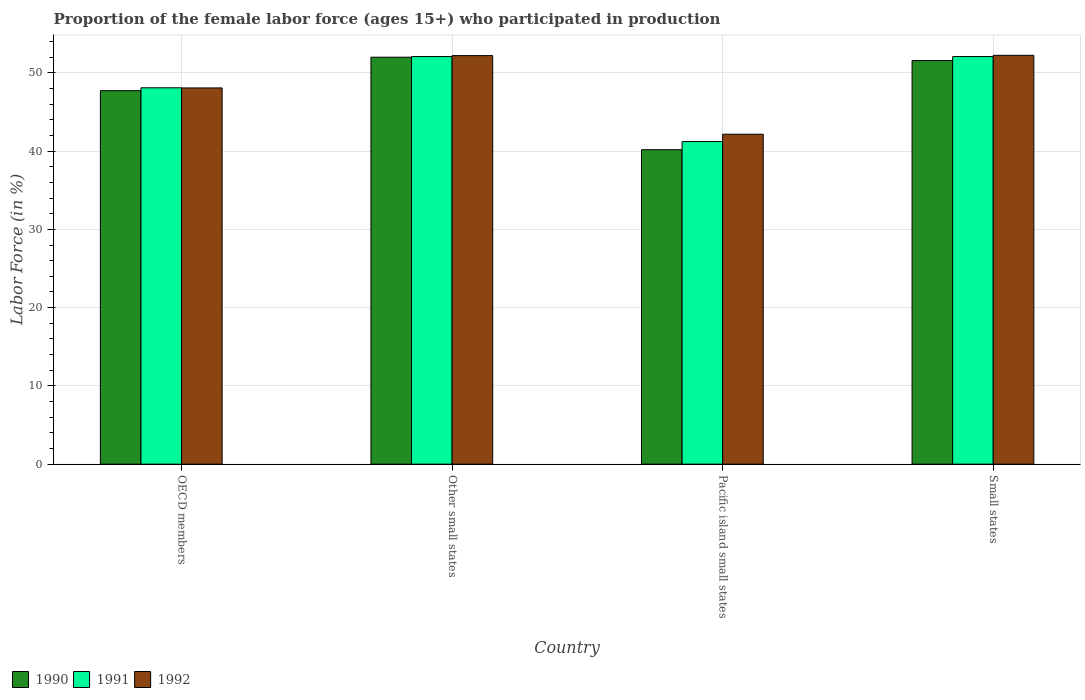How many different coloured bars are there?
Provide a succinct answer. 3. How many bars are there on the 4th tick from the right?
Provide a short and direct response. 3. What is the label of the 4th group of bars from the left?
Your answer should be compact. Small states. In how many cases, is the number of bars for a given country not equal to the number of legend labels?
Keep it short and to the point. 0. What is the proportion of the female labor force who participated in production in 1990 in Small states?
Your answer should be very brief. 51.57. Across all countries, what is the maximum proportion of the female labor force who participated in production in 1990?
Provide a succinct answer. 52. Across all countries, what is the minimum proportion of the female labor force who participated in production in 1990?
Your answer should be compact. 40.18. In which country was the proportion of the female labor force who participated in production in 1991 maximum?
Provide a short and direct response. Small states. In which country was the proportion of the female labor force who participated in production in 1990 minimum?
Your answer should be compact. Pacific island small states. What is the total proportion of the female labor force who participated in production in 1992 in the graph?
Offer a terse response. 194.66. What is the difference between the proportion of the female labor force who participated in production in 1991 in OECD members and that in Pacific island small states?
Ensure brevity in your answer.  6.87. What is the difference between the proportion of the female labor force who participated in production in 1991 in Pacific island small states and the proportion of the female labor force who participated in production in 1992 in Other small states?
Your answer should be compact. -10.98. What is the average proportion of the female labor force who participated in production in 1992 per country?
Your answer should be very brief. 48.66. What is the difference between the proportion of the female labor force who participated in production of/in 1991 and proportion of the female labor force who participated in production of/in 1990 in Other small states?
Make the answer very short. 0.08. What is the ratio of the proportion of the female labor force who participated in production in 1992 in OECD members to that in Pacific island small states?
Offer a terse response. 1.14. What is the difference between the highest and the second highest proportion of the female labor force who participated in production in 1990?
Provide a succinct answer. -0.43. What is the difference between the highest and the lowest proportion of the female labor force who participated in production in 1992?
Your response must be concise. 10.08. Is the sum of the proportion of the female labor force who participated in production in 1991 in Pacific island small states and Small states greater than the maximum proportion of the female labor force who participated in production in 1992 across all countries?
Offer a terse response. Yes. What does the 1st bar from the left in Other small states represents?
Your answer should be very brief. 1990. What does the 2nd bar from the right in Small states represents?
Your answer should be compact. 1991. How many bars are there?
Keep it short and to the point. 12. Does the graph contain grids?
Ensure brevity in your answer.  Yes. What is the title of the graph?
Make the answer very short. Proportion of the female labor force (ages 15+) who participated in production. What is the label or title of the X-axis?
Make the answer very short. Country. What is the Labor Force (in %) of 1990 in OECD members?
Your response must be concise. 47.72. What is the Labor Force (in %) in 1991 in OECD members?
Keep it short and to the point. 48.09. What is the Labor Force (in %) of 1992 in OECD members?
Your answer should be very brief. 48.07. What is the Labor Force (in %) of 1990 in Other small states?
Your answer should be compact. 52. What is the Labor Force (in %) in 1991 in Other small states?
Ensure brevity in your answer.  52.08. What is the Labor Force (in %) of 1992 in Other small states?
Provide a short and direct response. 52.2. What is the Labor Force (in %) of 1990 in Pacific island small states?
Your answer should be compact. 40.18. What is the Labor Force (in %) in 1991 in Pacific island small states?
Give a very brief answer. 41.21. What is the Labor Force (in %) in 1992 in Pacific island small states?
Give a very brief answer. 42.15. What is the Labor Force (in %) of 1990 in Small states?
Keep it short and to the point. 51.57. What is the Labor Force (in %) of 1991 in Small states?
Offer a terse response. 52.08. What is the Labor Force (in %) in 1992 in Small states?
Your answer should be very brief. 52.24. Across all countries, what is the maximum Labor Force (in %) of 1990?
Offer a terse response. 52. Across all countries, what is the maximum Labor Force (in %) of 1991?
Offer a terse response. 52.08. Across all countries, what is the maximum Labor Force (in %) of 1992?
Give a very brief answer. 52.24. Across all countries, what is the minimum Labor Force (in %) of 1990?
Ensure brevity in your answer.  40.18. Across all countries, what is the minimum Labor Force (in %) of 1991?
Ensure brevity in your answer.  41.21. Across all countries, what is the minimum Labor Force (in %) of 1992?
Keep it short and to the point. 42.15. What is the total Labor Force (in %) of 1990 in the graph?
Offer a very short reply. 191.46. What is the total Labor Force (in %) of 1991 in the graph?
Your response must be concise. 193.46. What is the total Labor Force (in %) of 1992 in the graph?
Provide a short and direct response. 194.66. What is the difference between the Labor Force (in %) of 1990 in OECD members and that in Other small states?
Provide a short and direct response. -4.28. What is the difference between the Labor Force (in %) in 1991 in OECD members and that in Other small states?
Ensure brevity in your answer.  -3.99. What is the difference between the Labor Force (in %) of 1992 in OECD members and that in Other small states?
Your response must be concise. -4.13. What is the difference between the Labor Force (in %) of 1990 in OECD members and that in Pacific island small states?
Offer a terse response. 7.54. What is the difference between the Labor Force (in %) of 1991 in OECD members and that in Pacific island small states?
Your answer should be very brief. 6.87. What is the difference between the Labor Force (in %) in 1992 in OECD members and that in Pacific island small states?
Your response must be concise. 5.92. What is the difference between the Labor Force (in %) of 1990 in OECD members and that in Small states?
Ensure brevity in your answer.  -3.85. What is the difference between the Labor Force (in %) in 1991 in OECD members and that in Small states?
Make the answer very short. -3.99. What is the difference between the Labor Force (in %) in 1992 in OECD members and that in Small states?
Provide a succinct answer. -4.17. What is the difference between the Labor Force (in %) in 1990 in Other small states and that in Pacific island small states?
Make the answer very short. 11.82. What is the difference between the Labor Force (in %) of 1991 in Other small states and that in Pacific island small states?
Your response must be concise. 10.86. What is the difference between the Labor Force (in %) in 1992 in Other small states and that in Pacific island small states?
Ensure brevity in your answer.  10.04. What is the difference between the Labor Force (in %) in 1990 in Other small states and that in Small states?
Your answer should be compact. 0.43. What is the difference between the Labor Force (in %) of 1991 in Other small states and that in Small states?
Your answer should be compact. -0. What is the difference between the Labor Force (in %) of 1992 in Other small states and that in Small states?
Your answer should be very brief. -0.04. What is the difference between the Labor Force (in %) in 1990 in Pacific island small states and that in Small states?
Your response must be concise. -11.39. What is the difference between the Labor Force (in %) of 1991 in Pacific island small states and that in Small states?
Offer a very short reply. -10.86. What is the difference between the Labor Force (in %) in 1992 in Pacific island small states and that in Small states?
Your response must be concise. -10.08. What is the difference between the Labor Force (in %) of 1990 in OECD members and the Labor Force (in %) of 1991 in Other small states?
Offer a terse response. -4.36. What is the difference between the Labor Force (in %) of 1990 in OECD members and the Labor Force (in %) of 1992 in Other small states?
Provide a succinct answer. -4.48. What is the difference between the Labor Force (in %) in 1991 in OECD members and the Labor Force (in %) in 1992 in Other small states?
Your answer should be compact. -4.11. What is the difference between the Labor Force (in %) in 1990 in OECD members and the Labor Force (in %) in 1991 in Pacific island small states?
Ensure brevity in your answer.  6.5. What is the difference between the Labor Force (in %) of 1990 in OECD members and the Labor Force (in %) of 1992 in Pacific island small states?
Offer a terse response. 5.57. What is the difference between the Labor Force (in %) in 1991 in OECD members and the Labor Force (in %) in 1992 in Pacific island small states?
Keep it short and to the point. 5.93. What is the difference between the Labor Force (in %) of 1990 in OECD members and the Labor Force (in %) of 1991 in Small states?
Your answer should be compact. -4.36. What is the difference between the Labor Force (in %) in 1990 in OECD members and the Labor Force (in %) in 1992 in Small states?
Keep it short and to the point. -4.52. What is the difference between the Labor Force (in %) of 1991 in OECD members and the Labor Force (in %) of 1992 in Small states?
Make the answer very short. -4.15. What is the difference between the Labor Force (in %) in 1990 in Other small states and the Labor Force (in %) in 1991 in Pacific island small states?
Your answer should be compact. 10.78. What is the difference between the Labor Force (in %) in 1990 in Other small states and the Labor Force (in %) in 1992 in Pacific island small states?
Provide a succinct answer. 9.84. What is the difference between the Labor Force (in %) of 1991 in Other small states and the Labor Force (in %) of 1992 in Pacific island small states?
Keep it short and to the point. 9.92. What is the difference between the Labor Force (in %) in 1990 in Other small states and the Labor Force (in %) in 1991 in Small states?
Give a very brief answer. -0.08. What is the difference between the Labor Force (in %) of 1990 in Other small states and the Labor Force (in %) of 1992 in Small states?
Provide a succinct answer. -0.24. What is the difference between the Labor Force (in %) of 1991 in Other small states and the Labor Force (in %) of 1992 in Small states?
Offer a very short reply. -0.16. What is the difference between the Labor Force (in %) in 1990 in Pacific island small states and the Labor Force (in %) in 1991 in Small states?
Your answer should be very brief. -11.9. What is the difference between the Labor Force (in %) of 1990 in Pacific island small states and the Labor Force (in %) of 1992 in Small states?
Offer a very short reply. -12.06. What is the difference between the Labor Force (in %) in 1991 in Pacific island small states and the Labor Force (in %) in 1992 in Small states?
Provide a succinct answer. -11.02. What is the average Labor Force (in %) in 1990 per country?
Ensure brevity in your answer.  47.86. What is the average Labor Force (in %) of 1991 per country?
Your response must be concise. 48.36. What is the average Labor Force (in %) of 1992 per country?
Your response must be concise. 48.66. What is the difference between the Labor Force (in %) in 1990 and Labor Force (in %) in 1991 in OECD members?
Provide a short and direct response. -0.37. What is the difference between the Labor Force (in %) in 1990 and Labor Force (in %) in 1992 in OECD members?
Your answer should be compact. -0.35. What is the difference between the Labor Force (in %) in 1991 and Labor Force (in %) in 1992 in OECD members?
Your answer should be compact. 0.02. What is the difference between the Labor Force (in %) of 1990 and Labor Force (in %) of 1991 in Other small states?
Offer a very short reply. -0.08. What is the difference between the Labor Force (in %) in 1990 and Labor Force (in %) in 1992 in Other small states?
Offer a terse response. -0.2. What is the difference between the Labor Force (in %) of 1991 and Labor Force (in %) of 1992 in Other small states?
Ensure brevity in your answer.  -0.12. What is the difference between the Labor Force (in %) of 1990 and Labor Force (in %) of 1991 in Pacific island small states?
Offer a very short reply. -1.04. What is the difference between the Labor Force (in %) in 1990 and Labor Force (in %) in 1992 in Pacific island small states?
Offer a terse response. -1.98. What is the difference between the Labor Force (in %) of 1991 and Labor Force (in %) of 1992 in Pacific island small states?
Offer a very short reply. -0.94. What is the difference between the Labor Force (in %) in 1990 and Labor Force (in %) in 1991 in Small states?
Your answer should be very brief. -0.51. What is the difference between the Labor Force (in %) in 1990 and Labor Force (in %) in 1992 in Small states?
Your answer should be very brief. -0.67. What is the difference between the Labor Force (in %) of 1991 and Labor Force (in %) of 1992 in Small states?
Give a very brief answer. -0.16. What is the ratio of the Labor Force (in %) in 1990 in OECD members to that in Other small states?
Provide a succinct answer. 0.92. What is the ratio of the Labor Force (in %) in 1991 in OECD members to that in Other small states?
Give a very brief answer. 0.92. What is the ratio of the Labor Force (in %) in 1992 in OECD members to that in Other small states?
Your answer should be very brief. 0.92. What is the ratio of the Labor Force (in %) of 1990 in OECD members to that in Pacific island small states?
Provide a succinct answer. 1.19. What is the ratio of the Labor Force (in %) of 1991 in OECD members to that in Pacific island small states?
Give a very brief answer. 1.17. What is the ratio of the Labor Force (in %) in 1992 in OECD members to that in Pacific island small states?
Offer a very short reply. 1.14. What is the ratio of the Labor Force (in %) in 1990 in OECD members to that in Small states?
Provide a succinct answer. 0.93. What is the ratio of the Labor Force (in %) in 1991 in OECD members to that in Small states?
Your response must be concise. 0.92. What is the ratio of the Labor Force (in %) of 1992 in OECD members to that in Small states?
Ensure brevity in your answer.  0.92. What is the ratio of the Labor Force (in %) of 1990 in Other small states to that in Pacific island small states?
Your answer should be compact. 1.29. What is the ratio of the Labor Force (in %) in 1991 in Other small states to that in Pacific island small states?
Keep it short and to the point. 1.26. What is the ratio of the Labor Force (in %) of 1992 in Other small states to that in Pacific island small states?
Provide a succinct answer. 1.24. What is the ratio of the Labor Force (in %) of 1990 in Other small states to that in Small states?
Make the answer very short. 1.01. What is the ratio of the Labor Force (in %) of 1990 in Pacific island small states to that in Small states?
Keep it short and to the point. 0.78. What is the ratio of the Labor Force (in %) of 1991 in Pacific island small states to that in Small states?
Offer a terse response. 0.79. What is the ratio of the Labor Force (in %) in 1992 in Pacific island small states to that in Small states?
Provide a short and direct response. 0.81. What is the difference between the highest and the second highest Labor Force (in %) in 1990?
Your answer should be very brief. 0.43. What is the difference between the highest and the second highest Labor Force (in %) in 1991?
Provide a succinct answer. 0. What is the difference between the highest and the second highest Labor Force (in %) of 1992?
Ensure brevity in your answer.  0.04. What is the difference between the highest and the lowest Labor Force (in %) in 1990?
Provide a short and direct response. 11.82. What is the difference between the highest and the lowest Labor Force (in %) of 1991?
Your answer should be compact. 10.86. What is the difference between the highest and the lowest Labor Force (in %) in 1992?
Provide a succinct answer. 10.08. 